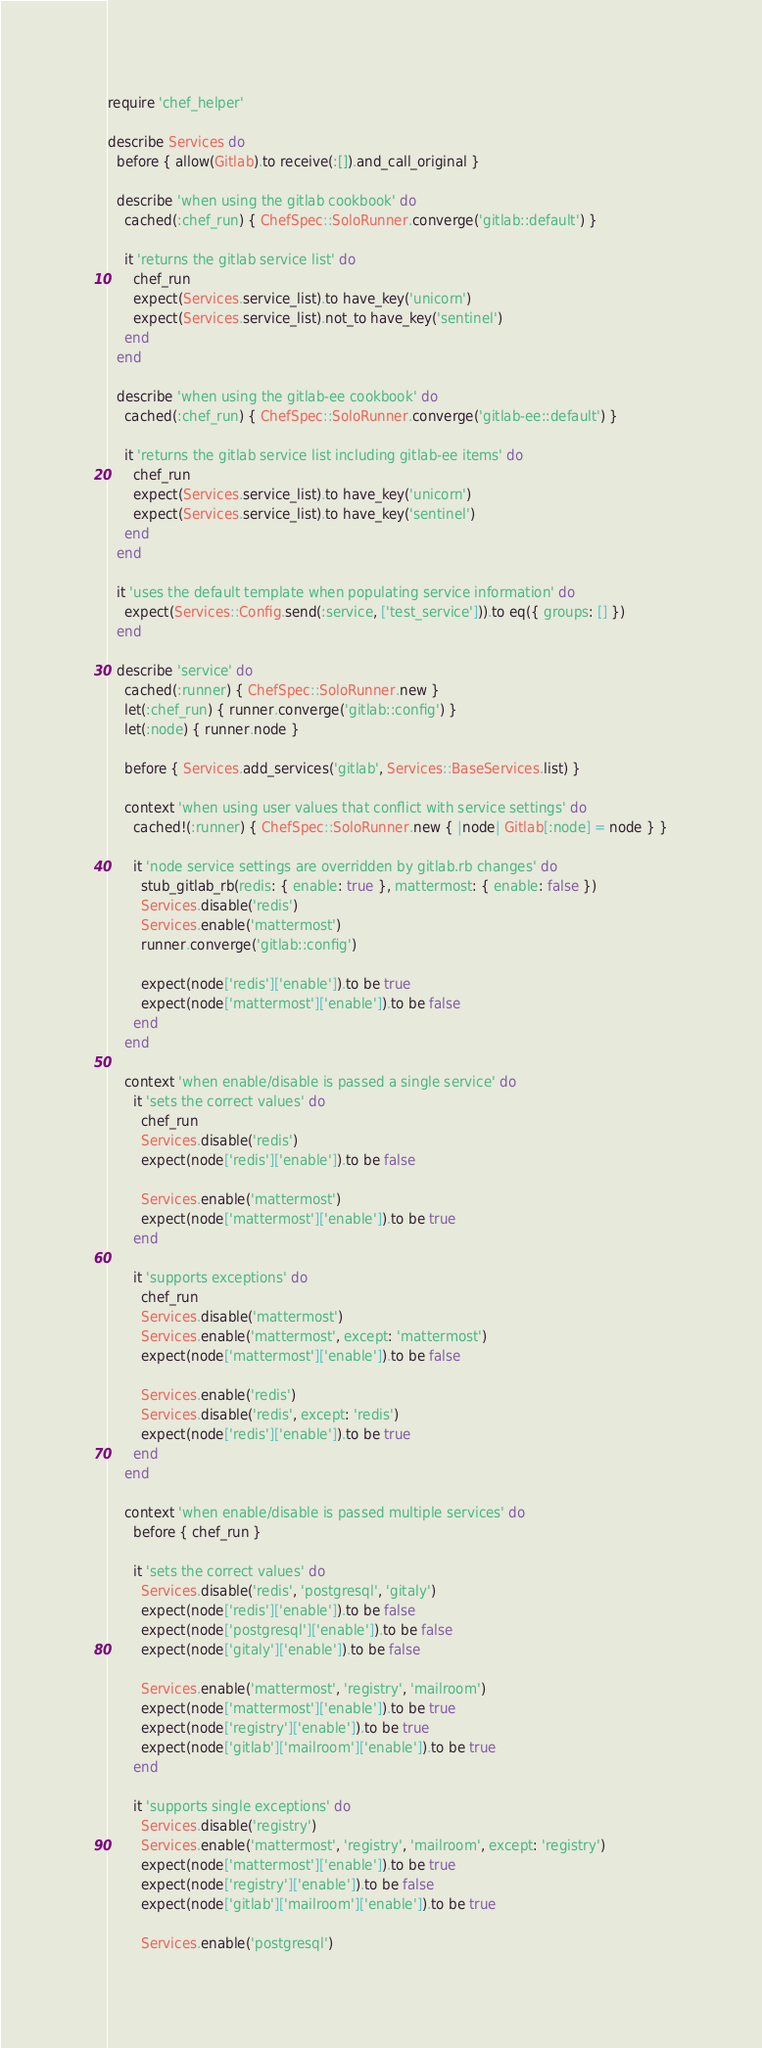Convert code to text. <code><loc_0><loc_0><loc_500><loc_500><_Ruby_>require 'chef_helper'

describe Services do
  before { allow(Gitlab).to receive(:[]).and_call_original }

  describe 'when using the gitlab cookbook' do
    cached(:chef_run) { ChefSpec::SoloRunner.converge('gitlab::default') }

    it 'returns the gitlab service list' do
      chef_run
      expect(Services.service_list).to have_key('unicorn')
      expect(Services.service_list).not_to have_key('sentinel')
    end
  end

  describe 'when using the gitlab-ee cookbook' do
    cached(:chef_run) { ChefSpec::SoloRunner.converge('gitlab-ee::default') }

    it 'returns the gitlab service list including gitlab-ee items' do
      chef_run
      expect(Services.service_list).to have_key('unicorn')
      expect(Services.service_list).to have_key('sentinel')
    end
  end

  it 'uses the default template when populating service information' do
    expect(Services::Config.send(:service, ['test_service'])).to eq({ groups: [] })
  end

  describe 'service' do
    cached(:runner) { ChefSpec::SoloRunner.new }
    let(:chef_run) { runner.converge('gitlab::config') }
    let(:node) { runner.node }

    before { Services.add_services('gitlab', Services::BaseServices.list) }

    context 'when using user values that conflict with service settings' do
      cached!(:runner) { ChefSpec::SoloRunner.new { |node| Gitlab[:node] = node } }

      it 'node service settings are overridden by gitlab.rb changes' do
        stub_gitlab_rb(redis: { enable: true }, mattermost: { enable: false })
        Services.disable('redis')
        Services.enable('mattermost')
        runner.converge('gitlab::config')

        expect(node['redis']['enable']).to be true
        expect(node['mattermost']['enable']).to be false
      end
    end

    context 'when enable/disable is passed a single service' do
      it 'sets the correct values' do
        chef_run
        Services.disable('redis')
        expect(node['redis']['enable']).to be false

        Services.enable('mattermost')
        expect(node['mattermost']['enable']).to be true
      end

      it 'supports exceptions' do
        chef_run
        Services.disable('mattermost')
        Services.enable('mattermost', except: 'mattermost')
        expect(node['mattermost']['enable']).to be false

        Services.enable('redis')
        Services.disable('redis', except: 'redis')
        expect(node['redis']['enable']).to be true
      end
    end

    context 'when enable/disable is passed multiple services' do
      before { chef_run }

      it 'sets the correct values' do
        Services.disable('redis', 'postgresql', 'gitaly')
        expect(node['redis']['enable']).to be false
        expect(node['postgresql']['enable']).to be false
        expect(node['gitaly']['enable']).to be false

        Services.enable('mattermost', 'registry', 'mailroom')
        expect(node['mattermost']['enable']).to be true
        expect(node['registry']['enable']).to be true
        expect(node['gitlab']['mailroom']['enable']).to be true
      end

      it 'supports single exceptions' do
        Services.disable('registry')
        Services.enable('mattermost', 'registry', 'mailroom', except: 'registry')
        expect(node['mattermost']['enable']).to be true
        expect(node['registry']['enable']).to be false
        expect(node['gitlab']['mailroom']['enable']).to be true

        Services.enable('postgresql')</code> 